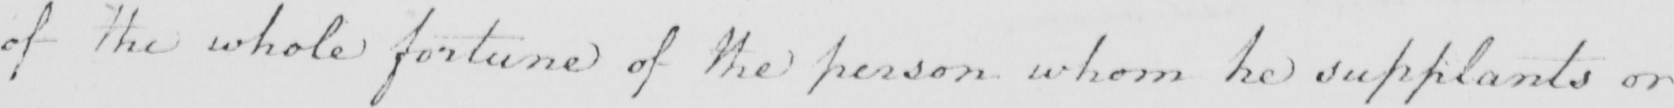Please transcribe the handwritten text in this image. of the whole fortune of the person whom he supplants or 